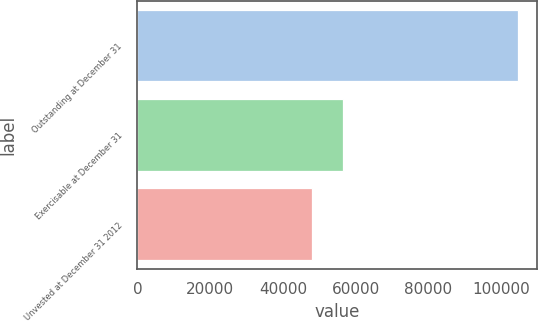Convert chart to OTSL. <chart><loc_0><loc_0><loc_500><loc_500><bar_chart><fcel>Outstanding at December 31<fcel>Exercisable at December 31<fcel>Unvested at December 31 2012<nl><fcel>104549<fcel>56545<fcel>48004<nl></chart> 